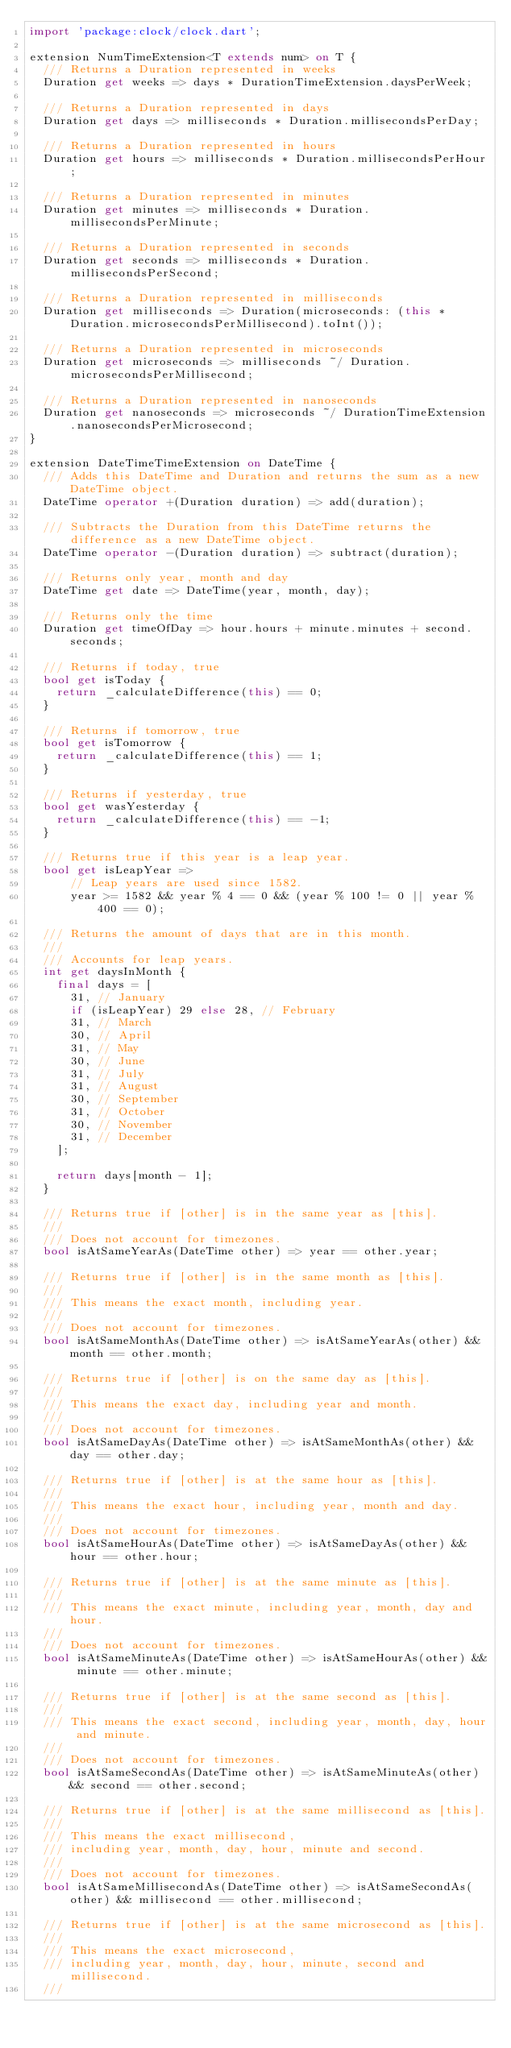Convert code to text. <code><loc_0><loc_0><loc_500><loc_500><_Dart_>import 'package:clock/clock.dart';

extension NumTimeExtension<T extends num> on T {
  /// Returns a Duration represented in weeks
  Duration get weeks => days * DurationTimeExtension.daysPerWeek;

  /// Returns a Duration represented in days
  Duration get days => milliseconds * Duration.millisecondsPerDay;

  /// Returns a Duration represented in hours
  Duration get hours => milliseconds * Duration.millisecondsPerHour;

  /// Returns a Duration represented in minutes
  Duration get minutes => milliseconds * Duration.millisecondsPerMinute;

  /// Returns a Duration represented in seconds
  Duration get seconds => milliseconds * Duration.millisecondsPerSecond;

  /// Returns a Duration represented in milliseconds
  Duration get milliseconds => Duration(microseconds: (this * Duration.microsecondsPerMillisecond).toInt());

  /// Returns a Duration represented in microseconds
  Duration get microseconds => milliseconds ~/ Duration.microsecondsPerMillisecond;

  /// Returns a Duration represented in nanoseconds
  Duration get nanoseconds => microseconds ~/ DurationTimeExtension.nanosecondsPerMicrosecond;
}

extension DateTimeTimeExtension on DateTime {
  /// Adds this DateTime and Duration and returns the sum as a new DateTime object.
  DateTime operator +(Duration duration) => add(duration);

  /// Subtracts the Duration from this DateTime returns the difference as a new DateTime object.
  DateTime operator -(Duration duration) => subtract(duration);

  /// Returns only year, month and day
  DateTime get date => DateTime(year, month, day);

  /// Returns only the time
  Duration get timeOfDay => hour.hours + minute.minutes + second.seconds;

  /// Returns if today, true
  bool get isToday {
    return _calculateDifference(this) == 0;
  }

  /// Returns if tomorrow, true
  bool get isTomorrow {
    return _calculateDifference(this) == 1;
  }

  /// Returns if yesterday, true
  bool get wasYesterday {
    return _calculateDifference(this) == -1;
  }

  /// Returns true if this year is a leap year.
  bool get isLeapYear =>
      // Leap years are used since 1582.
      year >= 1582 && year % 4 == 0 && (year % 100 != 0 || year % 400 == 0);

  /// Returns the amount of days that are in this month.
  ///
  /// Accounts for leap years.
  int get daysInMonth {
    final days = [
      31, // January
      if (isLeapYear) 29 else 28, // February
      31, // March
      30, // April
      31, // May
      30, // June
      31, // July
      31, // August
      30, // September
      31, // October
      30, // November
      31, // December
    ];

    return days[month - 1];
  }

  /// Returns true if [other] is in the same year as [this].
  ///
  /// Does not account for timezones.
  bool isAtSameYearAs(DateTime other) => year == other.year;

  /// Returns true if [other] is in the same month as [this].
  ///
  /// This means the exact month, including year.
  ///
  /// Does not account for timezones.
  bool isAtSameMonthAs(DateTime other) => isAtSameYearAs(other) && month == other.month;

  /// Returns true if [other] is on the same day as [this].
  ///
  /// This means the exact day, including year and month.
  ///
  /// Does not account for timezones.
  bool isAtSameDayAs(DateTime other) => isAtSameMonthAs(other) && day == other.day;

  /// Returns true if [other] is at the same hour as [this].
  ///
  /// This means the exact hour, including year, month and day.
  ///
  /// Does not account for timezones.
  bool isAtSameHourAs(DateTime other) => isAtSameDayAs(other) && hour == other.hour;

  /// Returns true if [other] is at the same minute as [this].
  ///
  /// This means the exact minute, including year, month, day and hour.
  ///
  /// Does not account for timezones.
  bool isAtSameMinuteAs(DateTime other) => isAtSameHourAs(other) && minute == other.minute;

  /// Returns true if [other] is at the same second as [this].
  ///
  /// This means the exact second, including year, month, day, hour and minute.
  ///
  /// Does not account for timezones.
  bool isAtSameSecondAs(DateTime other) => isAtSameMinuteAs(other) && second == other.second;

  /// Returns true if [other] is at the same millisecond as [this].
  ///
  /// This means the exact millisecond,
  /// including year, month, day, hour, minute and second.
  ///
  /// Does not account for timezones.
  bool isAtSameMillisecondAs(DateTime other) => isAtSameSecondAs(other) && millisecond == other.millisecond;

  /// Returns true if [other] is at the same microsecond as [this].
  ///
  /// This means the exact microsecond,
  /// including year, month, day, hour, minute, second and millisecond.
  ///</code> 